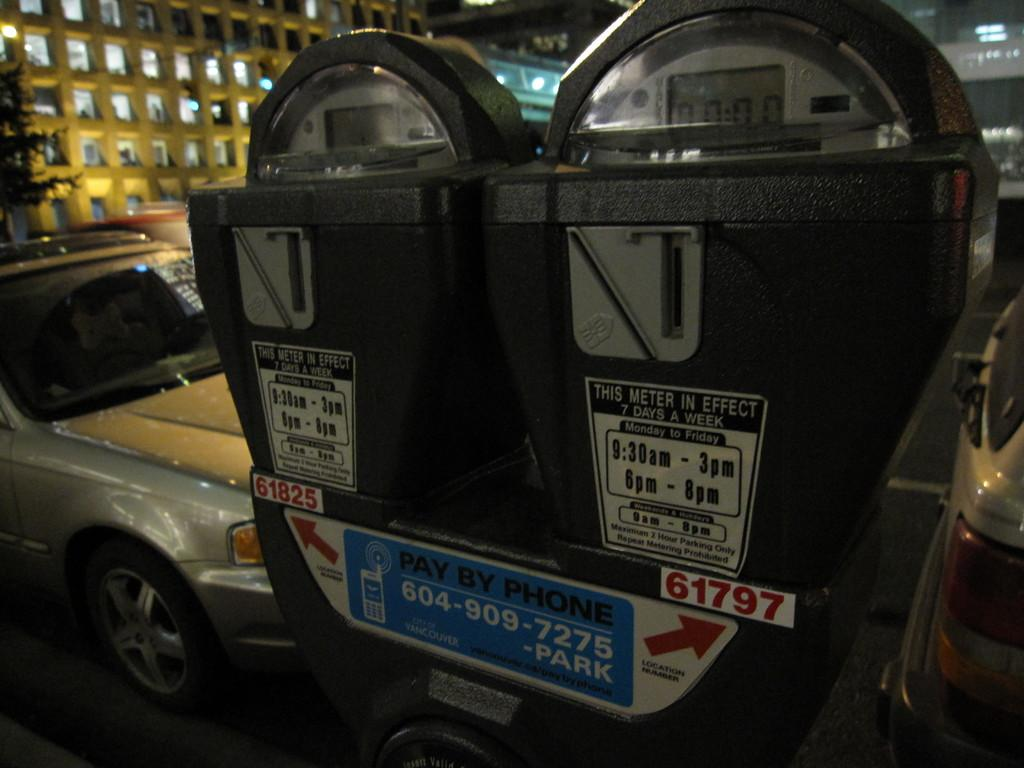<image>
Provide a brief description of the given image. Two parking meters that are designated 61825 and 61797 